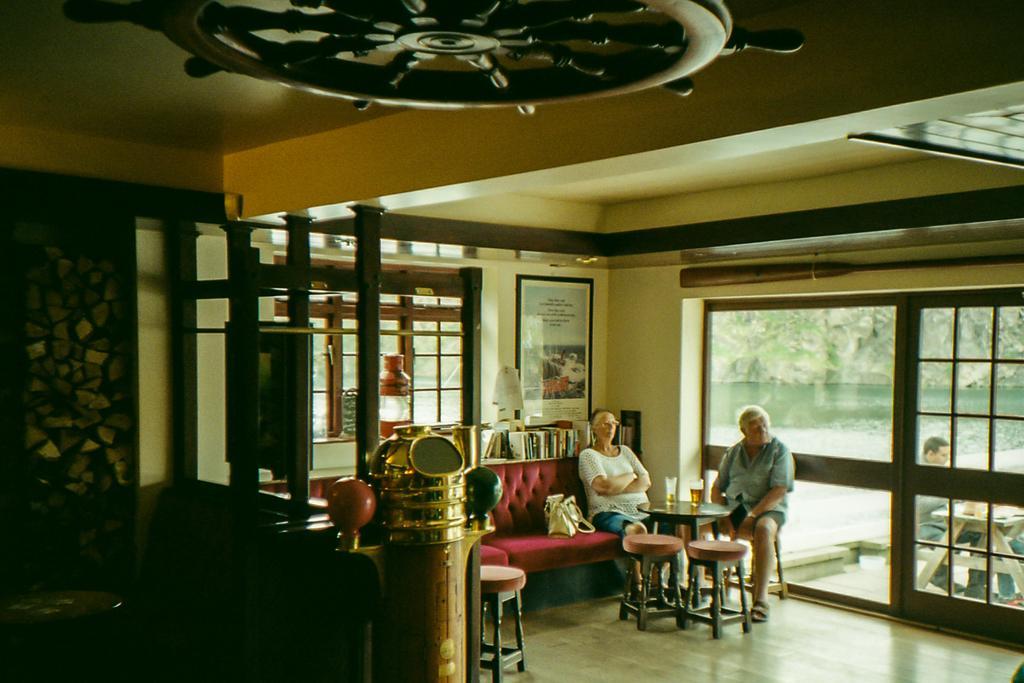Describe this image in one or two sentences. In the middle bottom two persons are sitting on the chair and sofa in front of the table on which glasses are kept. At the right bottom two persons are sitting on chair in front of the table and are half visible. A roof top is light yellow in color. The background walls are white and black in color and a window is visible and a wall painting is there. And a door is visible through which water and mountain is visible. This image is taken inside a house. 